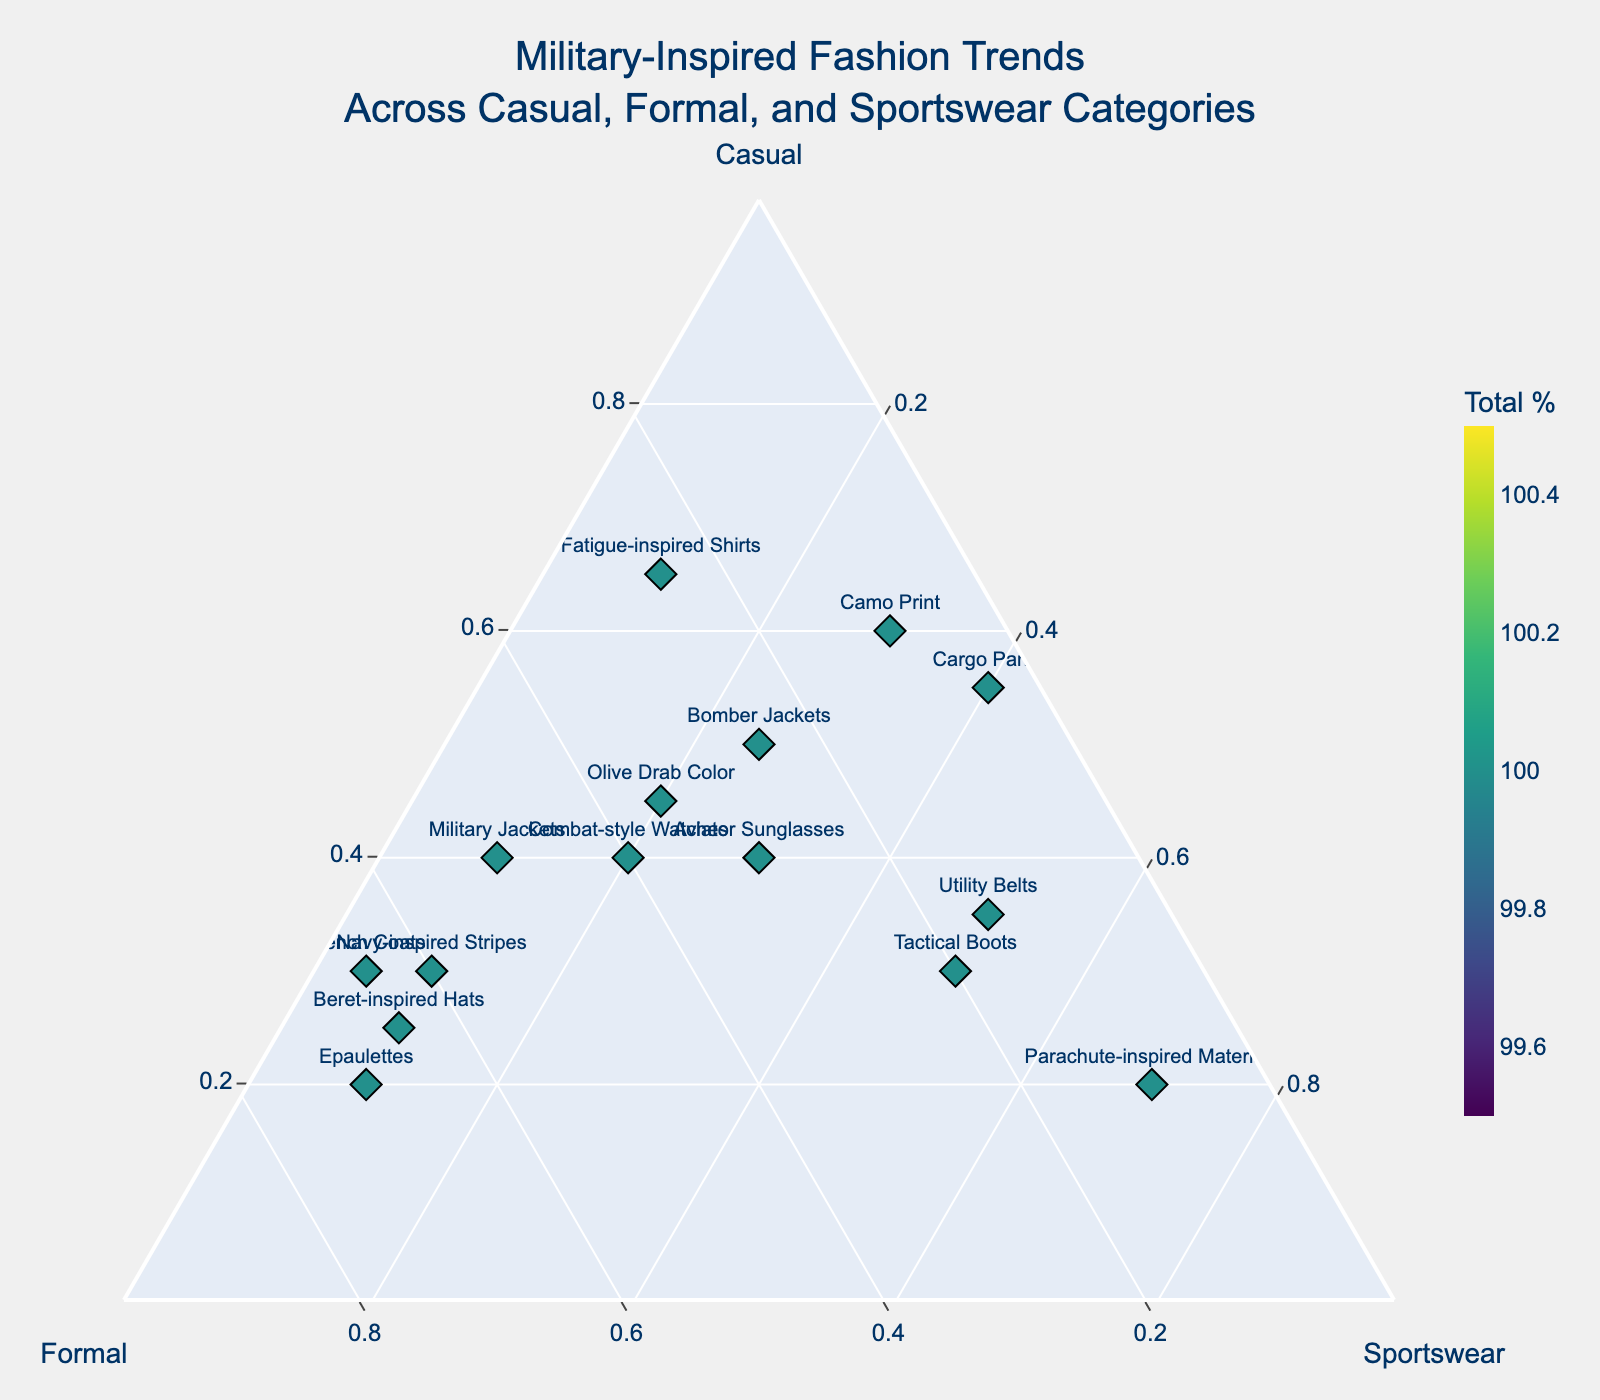what is the title of this plot? The title is plainly written at the top of the plot.
Answer: Military-Inspired Fashion Trends Across Casual, Formal, and Sportswear Categories what category has the highest proportion for Camo Print? In the plot, Camo Print is nearest to the vertex marked "Casual." This indicates that most of its composition is in the Casual category.
Answer: Casual which trend is closest to the Sportswear vertex? The point closest to the Sportswear vertex indicates the highest proportion of Sportswear. Parachute-inspired Materials are closest to that vertex, showing the highest Sportswear proportion.
Answer: Parachute-inspired Materials How many trends have more than 60% Formal composition? By analyzing the plot, you can count the points nearest to the Formal vertex and those having above 60% under the 'Formal' axis. Epaulettes, Beret-inspired Hats, Navy-inspired Stripes, and Trench Coats have more than 60%.
Answer: Four which trend balances equally across Casual and Formal categories? Aviator Sunglasses is positioned approximately equidistant from the Casual and Formal vertices, implying a balanced composition across Casual and Formal categories.
Answer: Aviator Sunglasses What is the trend with the lowest sum percentage value? The colorbar indicates that darker colors correspond to lower percentages. The darkest point on the plot is Camo Print, with the lowest combined percentage value.
Answer: Camo Print Can you identify the trend with the highest composition in Casual-Wear but least in Formal? The trend closest to the "Casual" vertex and farthest from the "Formal" vertex meets the criteria. Fatigue-inspired Shirts are closest to the Casual vertex and farthest from the Formal vertex.
Answer: Fatigue-inspired Shirts 